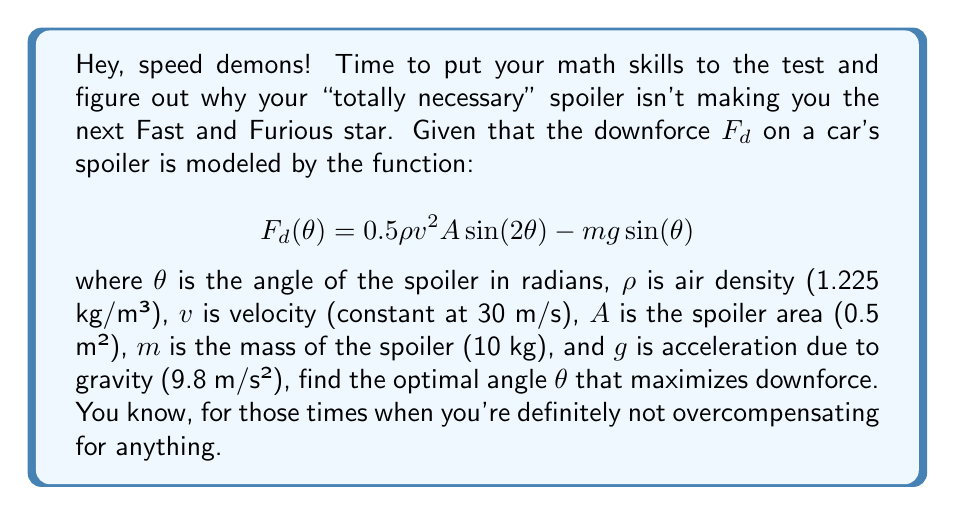Solve this math problem. Alright, gearheads, let's break this down step-by-step:

1) To find the maximum downforce, we need to find where the derivative of $F_d(\theta)$ equals zero. So, let's start by taking the derivative:

   $$\frac{d}{d\theta}F_d(\theta) = 0.5\rho v^2 A \cdot 2\cos(2\theta) - mg\cos(\theta)$$

2) Now, let's set this equal to zero and solve:

   $$0.5\rho v^2 A \cdot 2\cos(2\theta) - mg\cos(\theta) = 0$$

3) Substitute the given values:

   $$0.5 \cdot 1.225 \cdot 30^2 \cdot 0.5 \cdot 2\cos(2\theta) - 10 \cdot 9.8 \cos(\theta) = 0$$

4) Simplify:

   $$551.25\cos(2\theta) - 98\cos(\theta) = 0$$

5) Use the trigonometric identity $\cos(2\theta) = 2\cos^2(\theta) - 1$:

   $$551.25(2\cos^2(\theta) - 1) - 98\cos(\theta) = 0$$

6) Expand:

   $$1102.5\cos^2(\theta) - 551.25 - 98\cos(\theta) = 0$$

7) Rearrange into standard quadratic form:

   $$1102.5\cos^2(\theta) - 98\cos(\theta) - 551.25 = 0$$

8) Solve this quadratic equation in terms of $\cos(\theta)$ using the quadratic formula:

   $$\cos(\theta) = \frac{98 \pm \sqrt{98^2 + 4 \cdot 1102.5 \cdot 551.25}}{2 \cdot 1102.5}$$

9) Simplify:

   $$\cos(\theta) \approx 0.7071 \text{ or } -0.7117$$

10) Since $\theta$ is an angle of a spoiler, we're only interested in the positive solution. Therefore:

    $$\theta = \arccos(0.7071) \approx 0.7854 \text{ radians}$$

11) Convert to degrees:

    $$\theta \approx 45^\circ$$

Therefore, the optimal angle for maximum downforce is approximately 45°.
Answer: The optimal angle $\theta$ that maximizes downforce is approximately 45°. 